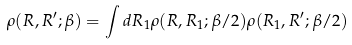<formula> <loc_0><loc_0><loc_500><loc_500>\rho ( R , R ^ { \prime } ; \beta ) = \int { d R _ { 1 } \rho ( R , R _ { 1 } ; \beta / 2 ) \rho ( R _ { 1 } , R ^ { \prime } ; \beta / 2 ) }</formula> 